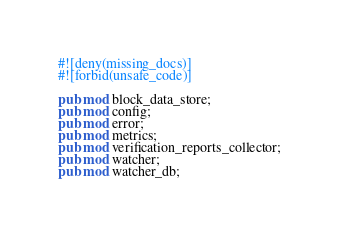Convert code to text. <code><loc_0><loc_0><loc_500><loc_500><_Rust_>#![deny(missing_docs)]
#![forbid(unsafe_code)]

pub mod block_data_store;
pub mod config;
pub mod error;
pub mod metrics;
pub mod verification_reports_collector;
pub mod watcher;
pub mod watcher_db;
</code> 